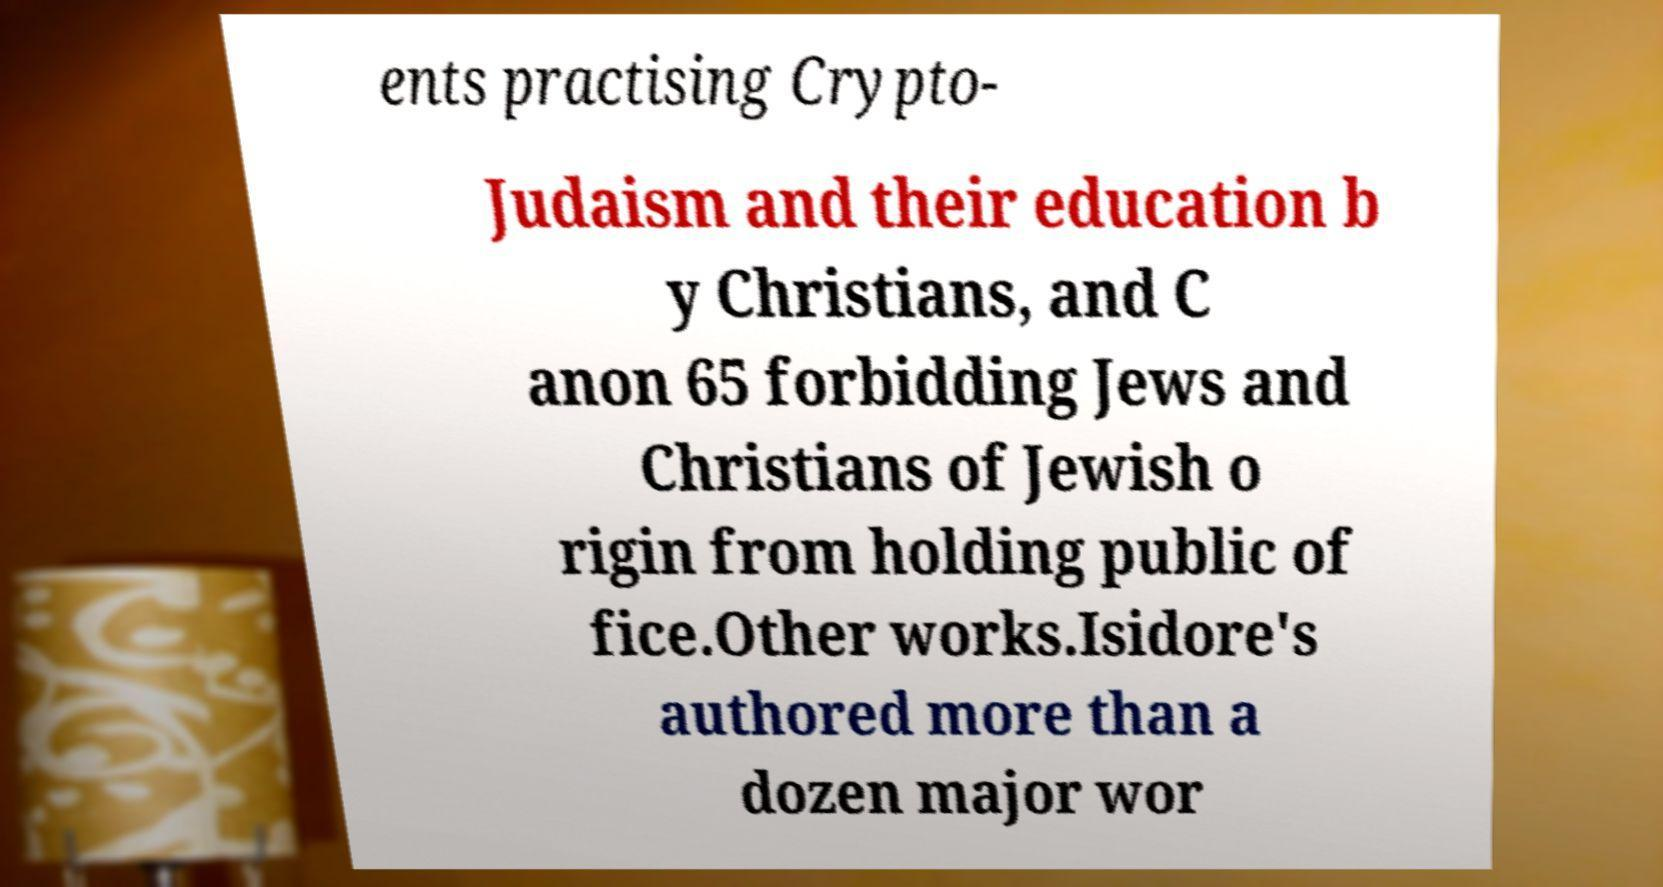For documentation purposes, I need the text within this image transcribed. Could you provide that? ents practising Crypto- Judaism and their education b y Christians, and C anon 65 forbidding Jews and Christians of Jewish o rigin from holding public of fice.Other works.Isidore's authored more than a dozen major wor 